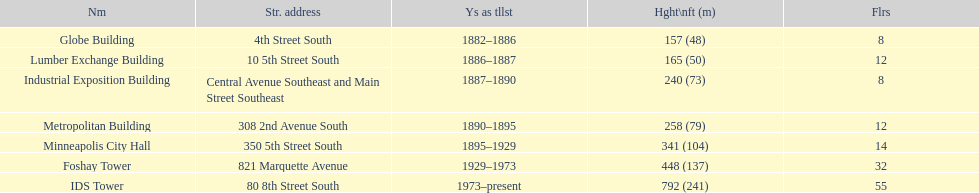How long did the lumber exchange building stand as the tallest building? 1 year. 